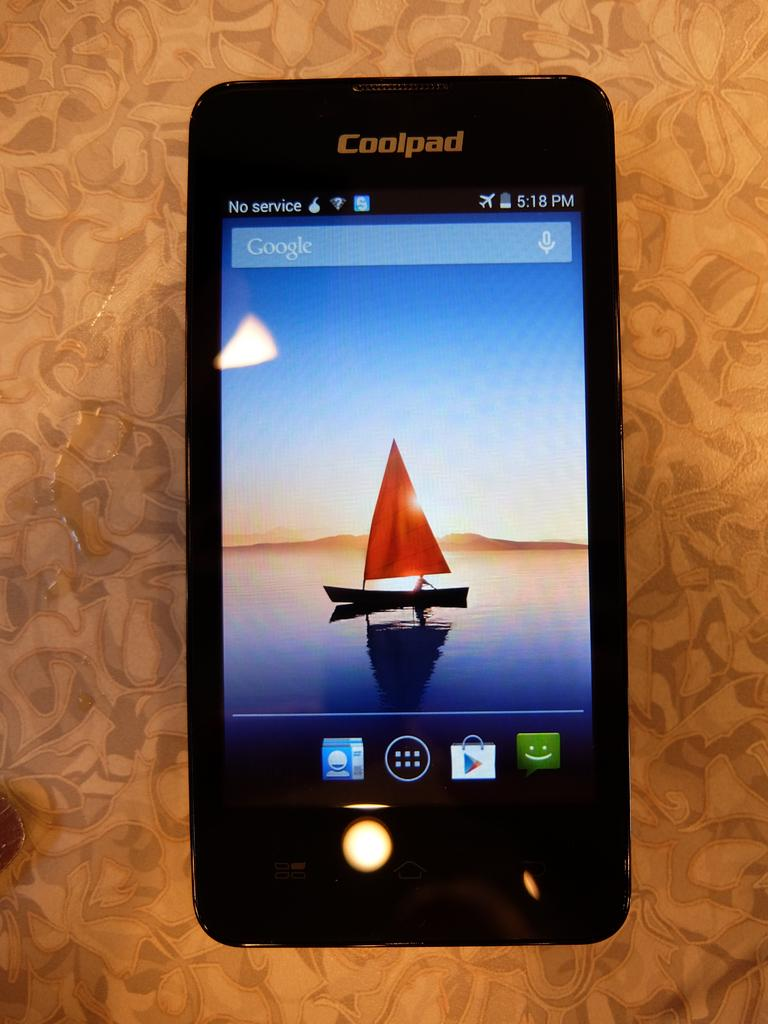<image>
Render a clear and concise summary of the photo. A smart phone says Coolpad and has a sailboat in the wallpaper. 